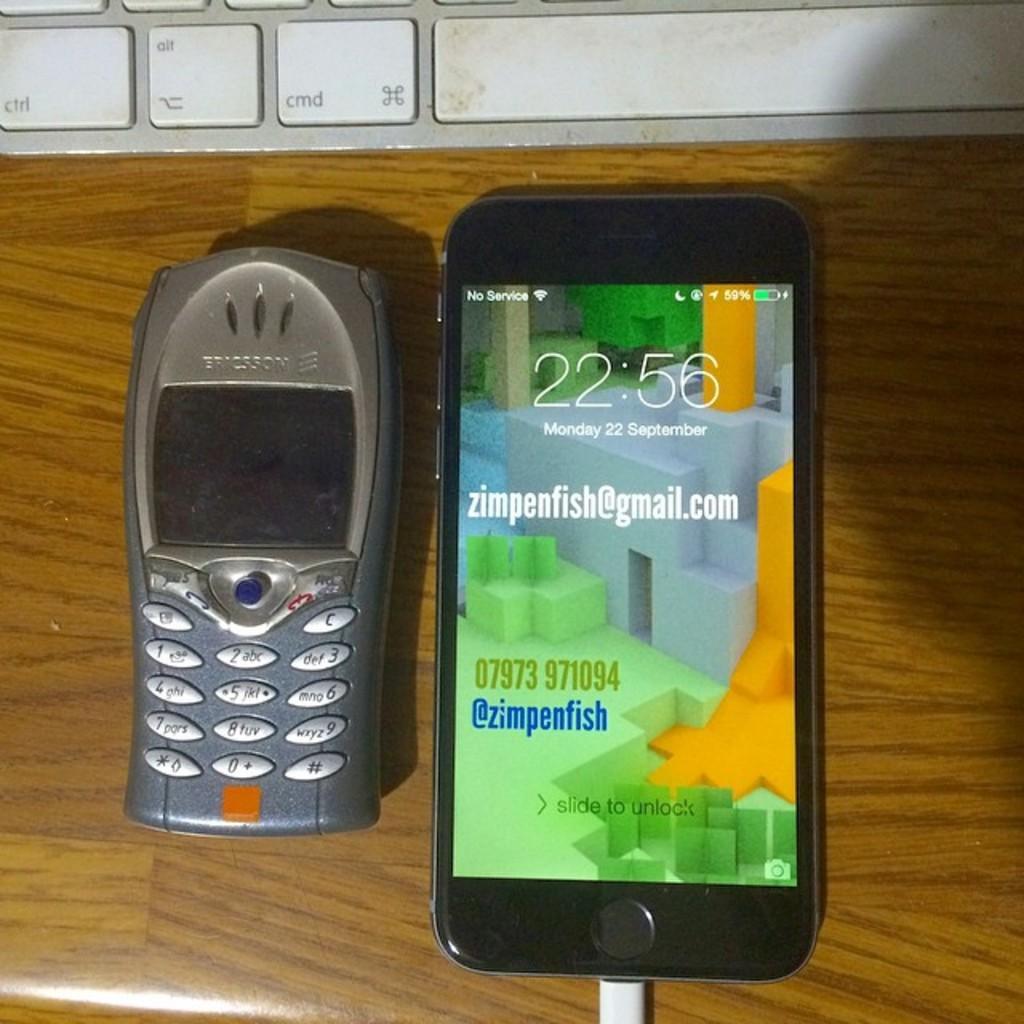Please provide a concise description of this image. In this image there are mobile phones and on the top there is a keyboard which are on the surface which is brown in colour. 